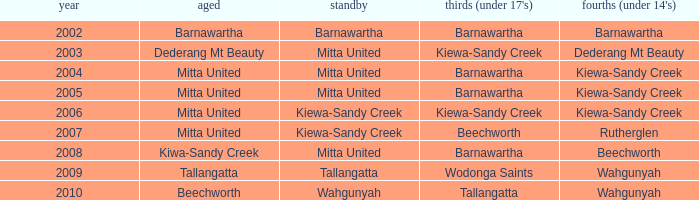Which Fourths (Under 14's) have Seniors of dederang mt beauty? Dederang Mt Beauty. 